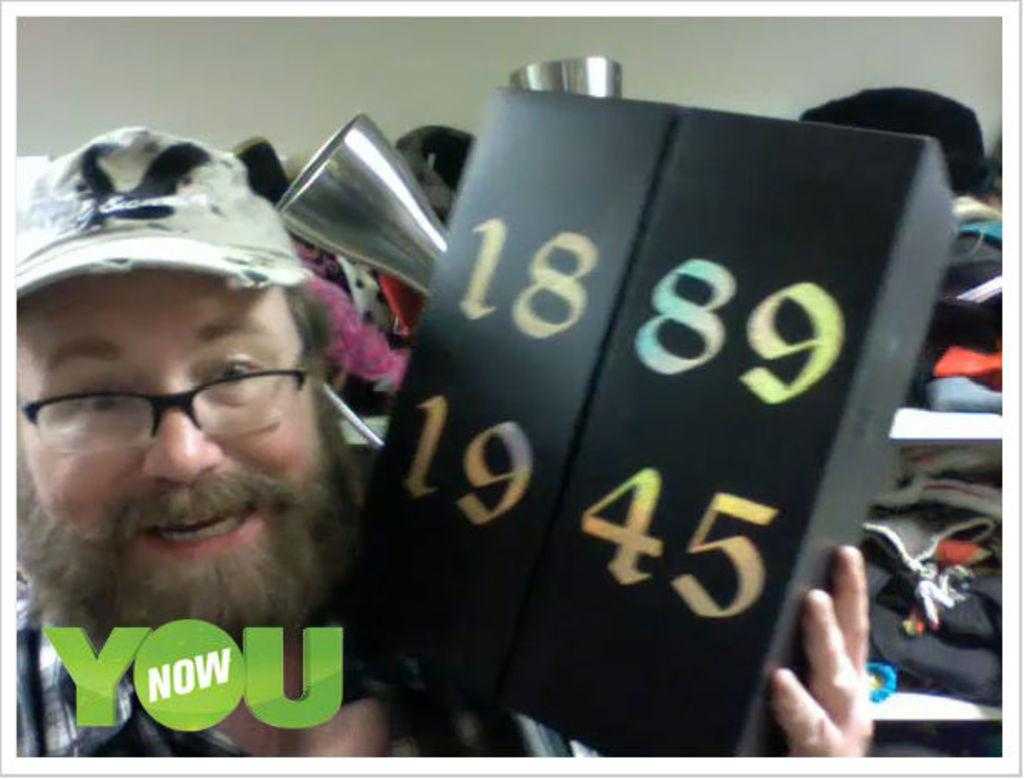Who is present in the image? There is a person in the image. What can be observed about the person's appearance? The person is wearing spectacles. What is the person holding in the image? The person is holding a box. What information can be gathered from the box? There are numbers visible on the box. What can be seen in the background of the image? There are shelves with clothes in the background of the image. What channel is the person watching on the television in the image? There is no television present in the image, so it is not possible to determine what channel the person might be watching. 